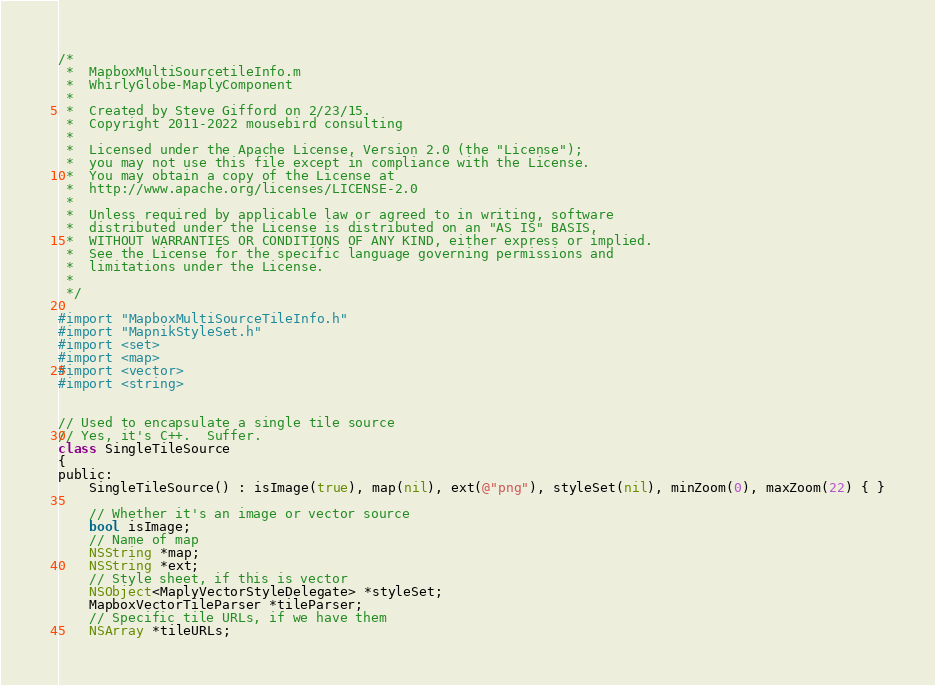Convert code to text. <code><loc_0><loc_0><loc_500><loc_500><_ObjectiveC_>/*
 *  MapboxMultiSourcetileInfo.m
 *  WhirlyGlobe-MaplyComponent
 *
 *  Created by Steve Gifford on 2/23/15.
 *  Copyright 2011-2022 mousebird consulting
 *
 *  Licensed under the Apache License, Version 2.0 (the "License");
 *  you may not use this file except in compliance with the License.
 *  You may obtain a copy of the License at
 *  http://www.apache.org/licenses/LICENSE-2.0
 *
 *  Unless required by applicable law or agreed to in writing, software
 *  distributed under the License is distributed on an "AS IS" BASIS,
 *  WITHOUT WARRANTIES OR CONDITIONS OF ANY KIND, either express or implied.
 *  See the License for the specific language governing permissions and
 *  limitations under the License.
 *
 */

#import "MapboxMultiSourceTileInfo.h"
#import "MapnikStyleSet.h"
#import <set>
#import <map>
#import <vector>
#import <string>


// Used to encapsulate a single tile source
// Yes, it's C++.  Suffer.
class SingleTileSource
{
public:
    SingleTileSource() : isImage(true), map(nil), ext(@"png"), styleSet(nil), minZoom(0), maxZoom(22) { }
    
    // Whether it's an image or vector source
    bool isImage;
    // Name of map
    NSString *map;
    NSString *ext;
    // Style sheet, if this is vector
    NSObject<MaplyVectorStyleDelegate> *styleSet;
    MapboxVectorTileParser *tileParser;
    // Specific tile URLs, if we have them
    NSArray *tileURLs;</code> 